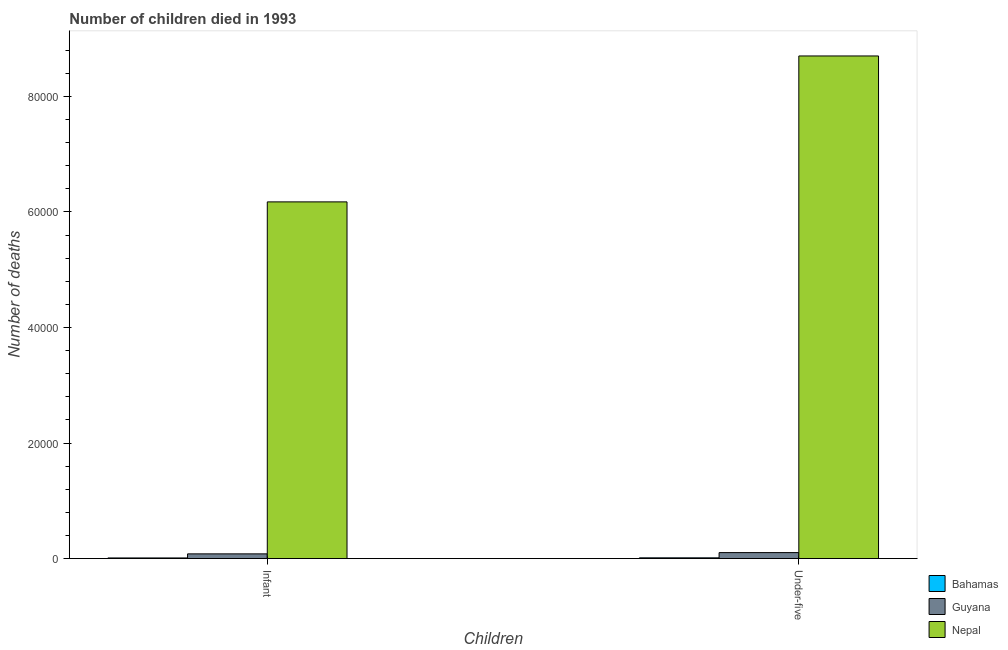How many groups of bars are there?
Provide a short and direct response. 2. Are the number of bars per tick equal to the number of legend labels?
Provide a succinct answer. Yes. Are the number of bars on each tick of the X-axis equal?
Offer a terse response. Yes. What is the label of the 1st group of bars from the left?
Your answer should be compact. Infant. What is the number of under-five deaths in Bahamas?
Give a very brief answer. 128. Across all countries, what is the maximum number of under-five deaths?
Offer a very short reply. 8.70e+04. Across all countries, what is the minimum number of under-five deaths?
Offer a terse response. 128. In which country was the number of under-five deaths maximum?
Your response must be concise. Nepal. In which country was the number of infant deaths minimum?
Offer a terse response. Bahamas. What is the total number of infant deaths in the graph?
Provide a succinct answer. 6.27e+04. What is the difference between the number of infant deaths in Nepal and that in Guyana?
Offer a very short reply. 6.09e+04. What is the difference between the number of infant deaths in Guyana and the number of under-five deaths in Nepal?
Provide a short and direct response. -8.62e+04. What is the average number of under-five deaths per country?
Offer a terse response. 2.94e+04. What is the difference between the number of infant deaths and number of under-five deaths in Guyana?
Keep it short and to the point. -221. What is the ratio of the number of infant deaths in Bahamas to that in Nepal?
Your response must be concise. 0. Is the number of infant deaths in Nepal less than that in Bahamas?
Keep it short and to the point. No. What does the 2nd bar from the left in Under-five represents?
Your answer should be compact. Guyana. What does the 1st bar from the right in Infant represents?
Provide a short and direct response. Nepal. How many bars are there?
Your response must be concise. 6. How many countries are there in the graph?
Make the answer very short. 3. What is the difference between two consecutive major ticks on the Y-axis?
Ensure brevity in your answer.  2.00e+04. Are the values on the major ticks of Y-axis written in scientific E-notation?
Your answer should be compact. No. Does the graph contain any zero values?
Provide a short and direct response. No. Where does the legend appear in the graph?
Offer a terse response. Bottom right. What is the title of the graph?
Your answer should be very brief. Number of children died in 1993. What is the label or title of the X-axis?
Provide a short and direct response. Children. What is the label or title of the Y-axis?
Your answer should be very brief. Number of deaths. What is the Number of deaths of Bahamas in Infant?
Ensure brevity in your answer.  108. What is the Number of deaths in Guyana in Infant?
Your answer should be very brief. 813. What is the Number of deaths of Nepal in Infant?
Keep it short and to the point. 6.17e+04. What is the Number of deaths in Bahamas in Under-five?
Your answer should be very brief. 128. What is the Number of deaths in Guyana in Under-five?
Your answer should be compact. 1034. What is the Number of deaths in Nepal in Under-five?
Ensure brevity in your answer.  8.70e+04. Across all Children, what is the maximum Number of deaths in Bahamas?
Make the answer very short. 128. Across all Children, what is the maximum Number of deaths in Guyana?
Your answer should be very brief. 1034. Across all Children, what is the maximum Number of deaths in Nepal?
Offer a terse response. 8.70e+04. Across all Children, what is the minimum Number of deaths in Bahamas?
Your response must be concise. 108. Across all Children, what is the minimum Number of deaths in Guyana?
Your answer should be compact. 813. Across all Children, what is the minimum Number of deaths of Nepal?
Keep it short and to the point. 6.17e+04. What is the total Number of deaths in Bahamas in the graph?
Your answer should be very brief. 236. What is the total Number of deaths of Guyana in the graph?
Offer a terse response. 1847. What is the total Number of deaths of Nepal in the graph?
Your response must be concise. 1.49e+05. What is the difference between the Number of deaths of Bahamas in Infant and that in Under-five?
Provide a short and direct response. -20. What is the difference between the Number of deaths of Guyana in Infant and that in Under-five?
Give a very brief answer. -221. What is the difference between the Number of deaths of Nepal in Infant and that in Under-five?
Offer a terse response. -2.53e+04. What is the difference between the Number of deaths in Bahamas in Infant and the Number of deaths in Guyana in Under-five?
Make the answer very short. -926. What is the difference between the Number of deaths in Bahamas in Infant and the Number of deaths in Nepal in Under-five?
Provide a short and direct response. -8.69e+04. What is the difference between the Number of deaths of Guyana in Infant and the Number of deaths of Nepal in Under-five?
Offer a very short reply. -8.62e+04. What is the average Number of deaths of Bahamas per Children?
Offer a terse response. 118. What is the average Number of deaths of Guyana per Children?
Keep it short and to the point. 923.5. What is the average Number of deaths of Nepal per Children?
Keep it short and to the point. 7.44e+04. What is the difference between the Number of deaths of Bahamas and Number of deaths of Guyana in Infant?
Offer a very short reply. -705. What is the difference between the Number of deaths of Bahamas and Number of deaths of Nepal in Infant?
Offer a terse response. -6.16e+04. What is the difference between the Number of deaths of Guyana and Number of deaths of Nepal in Infant?
Provide a succinct answer. -6.09e+04. What is the difference between the Number of deaths in Bahamas and Number of deaths in Guyana in Under-five?
Your answer should be compact. -906. What is the difference between the Number of deaths of Bahamas and Number of deaths of Nepal in Under-five?
Provide a succinct answer. -8.69e+04. What is the difference between the Number of deaths in Guyana and Number of deaths in Nepal in Under-five?
Offer a very short reply. -8.60e+04. What is the ratio of the Number of deaths in Bahamas in Infant to that in Under-five?
Offer a very short reply. 0.84. What is the ratio of the Number of deaths of Guyana in Infant to that in Under-five?
Ensure brevity in your answer.  0.79. What is the ratio of the Number of deaths in Nepal in Infant to that in Under-five?
Give a very brief answer. 0.71. What is the difference between the highest and the second highest Number of deaths in Bahamas?
Give a very brief answer. 20. What is the difference between the highest and the second highest Number of deaths in Guyana?
Your answer should be very brief. 221. What is the difference between the highest and the second highest Number of deaths in Nepal?
Offer a terse response. 2.53e+04. What is the difference between the highest and the lowest Number of deaths of Guyana?
Make the answer very short. 221. What is the difference between the highest and the lowest Number of deaths in Nepal?
Offer a very short reply. 2.53e+04. 